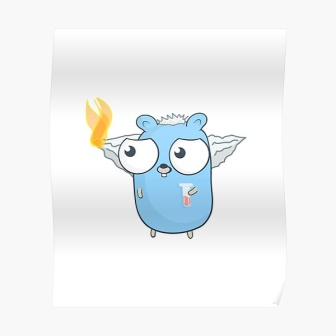On a deeper note, how might this creature reflect themes of resilience and self-sacrifice in the forest community? The creature exemplifies resilience through its continued duties despite its visible ailment. An encounter with a fire spirit left it bearing the flame—a symbol of both its burden and its bravery. Through unwavering dedication to its role as a guardian, it embodies the forest's collective resilience, facing threats and challenges head-on. Its self-sacrifice is a deeply respected principle—the community holds annual rites honoring such bravery, fostering a culture of mutual support and admiration. The creature’s ongoing efforts, despite personal suffering, inspire other inhabitants to persevere and protect their magical home, reflecting the intertwined fates and responsibilities within their interconnected world. 